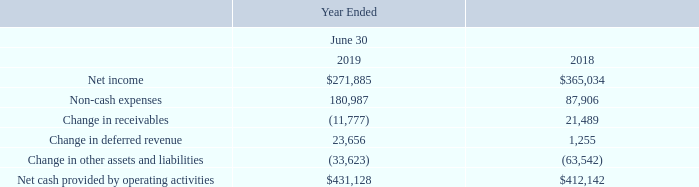LIQUIDITY AND CAPITAL RESOURCES
The Company’s cash and cash equivalents increased to $93,628 at June 30, 2019 from $31,440 at June 30, 2018. Cash at the end of fiscal 2018 was lower due primarily to the acquisition of Ensenta and higher repayment of debt in fiscal 2018.
The following table summarizes net cash from operating activities in the statement of cash flows:
Cash provided by operating activities increased 5% compared to fiscal 2018. Cash from operations is primarily used to repay debt, pay dividends and repurchase stock, and for capital expenditures.
What is the net income in 2018 and 2019 respectively? $365,034, $271,885. What is the non-cash expenses in 2018 and 2019 respectively? 87,906, 180,987. What does the table show? Summarizes net cash from operating activities in the statement of cash flows. What is the change in net cash provided by operating activities from 2018 to 2019? $431,128-$412,142
Answer: 18986. What is the average net income for 2018 and 2019? ($271,885+$365,034)/2
Answer: 318459.5. What is the average net cash provided by operating activities for 2018 and 2019? ($431,128+$412,142)/2
Answer: 421635. 